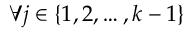<formula> <loc_0><loc_0><loc_500><loc_500>\forall j \in \{ 1 , 2 , \dots , k - 1 \}</formula> 